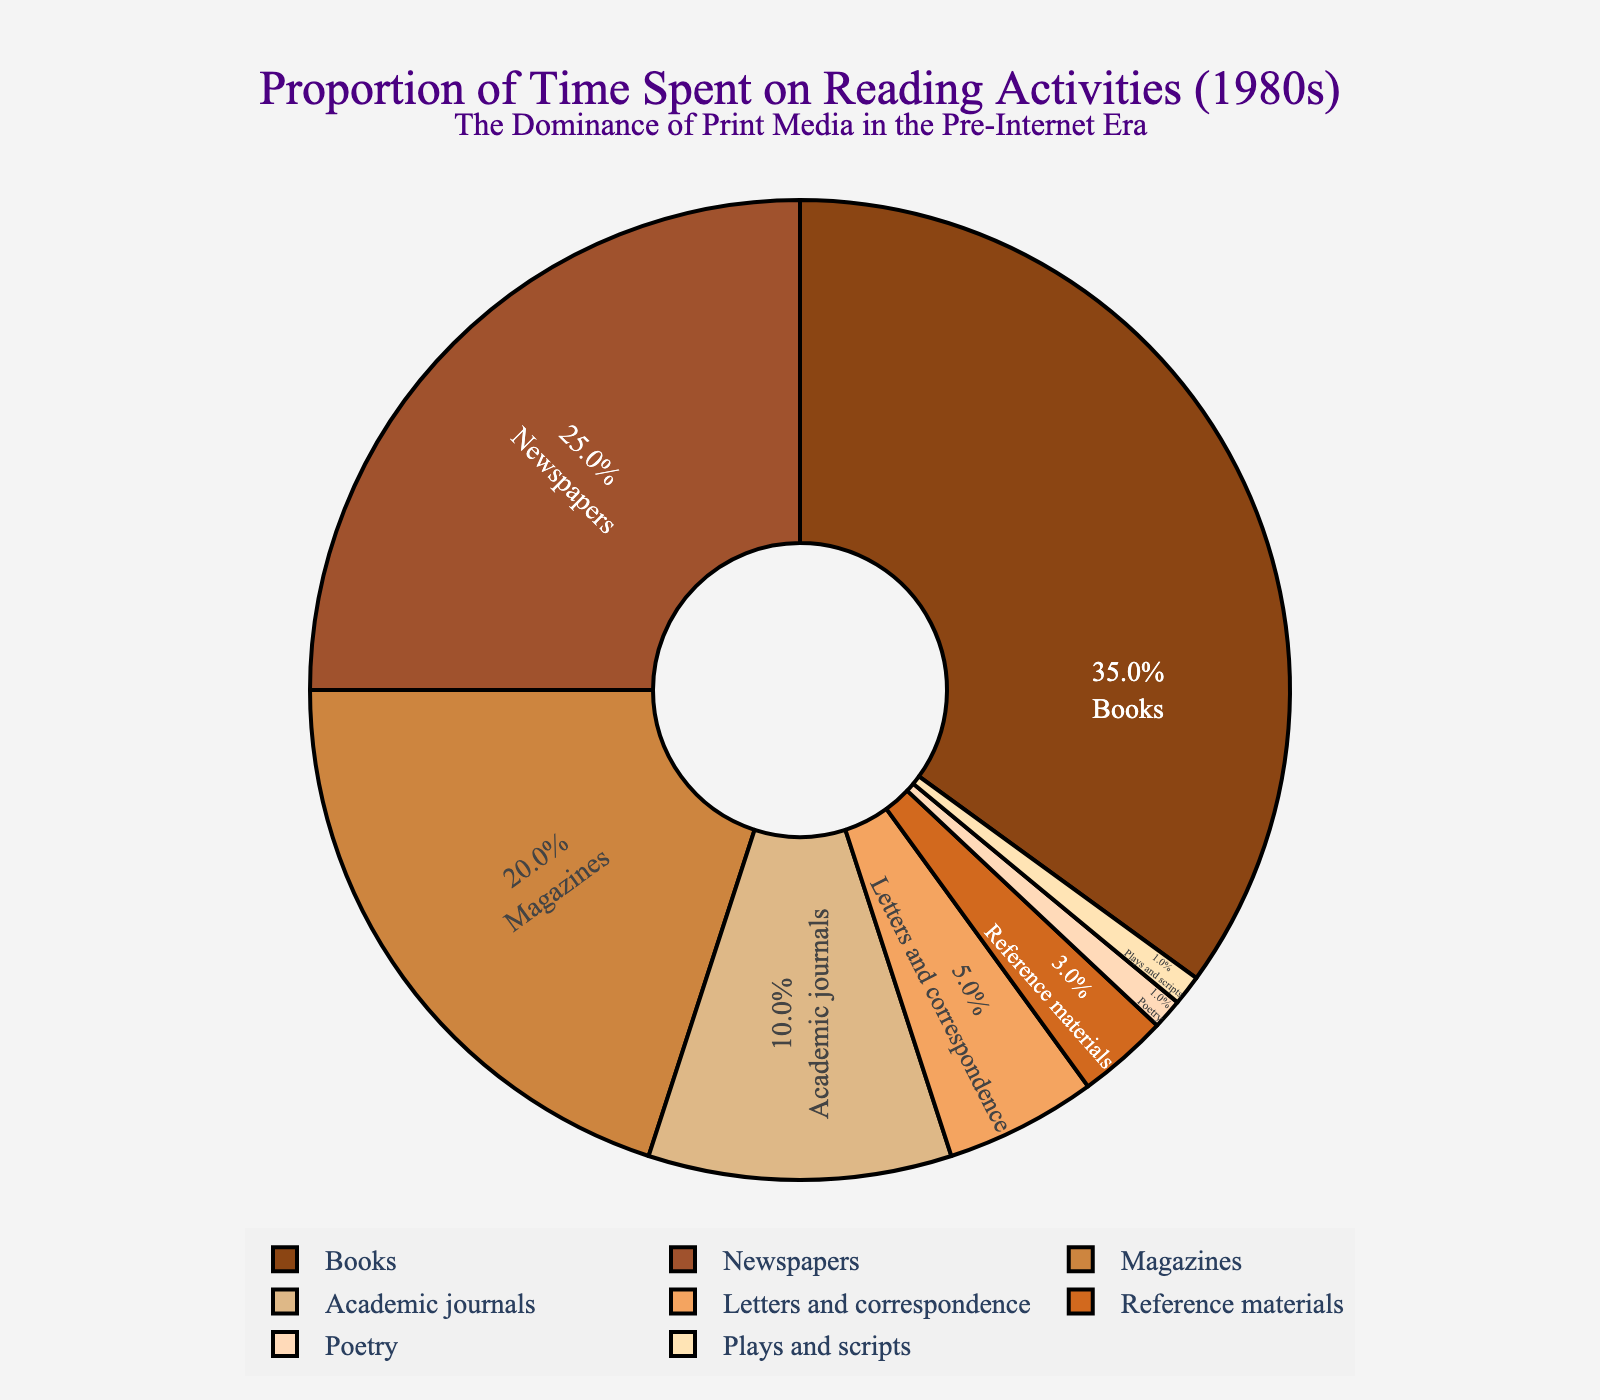What activity accounted for the highest proportion of reading time in the 1980s? The figure shows that "Books" is the largest segment, indicating that they accounted for the highest proportion of reading time.
Answer: Books How much more time was spent reading books compared to magazines? The figure shows that 35% of the time was spent on books and 20% on magazines. The difference is calculated as 35% - 20% = 15%.
Answer: 15% What is the combined percentage of time spent reading newspapers and academic journals? The figure shows that newspapers account for 25% and academic journals for 10%. Summing these gives 25% + 10% = 35%.
Answer: 35% Which reading activities each accounted for the least percentage of time and what is their combined total percentage? The figure shows that both "Poetry" and "Plays and scripts" account for 1% each. Their combined total is 1% + 1% = 2%.
Answer: Poetry and Plays and scripts, 2% How much time in total was devoted to reading letters, reference materials, poetry, and plays? According to the figure, letters account for 5%, reference materials for 3%, poetry for 1%, and plays for 1%. Summing these gives 5% + 3% + 1% + 1% = 10%.
Answer: 10% Which activity is closer in proportion to academic journals: magazines or letters and correspondence? The figure shows that academic journals account for 10%, magazines 20%, and letters and correspondence 5%. The difference with magazines is 20% - 10% = 10%, and with letters and correspondence, it is 10% - 5% = 5%. Since 5% is smaller than 10%, letters and correspondence are closer in proportion.
Answer: Letters and correspondence What is the ratio of time spent reading books to newspapers? The figure shows that 35% of the time was spent on books and 25% on newspapers. The ratio is calculated as 35:25, which simplifies to 7:5.
Answer: 7:5 By how much does the time spent on books exceed the combined time spent on reference materials and plays? The figure shows that 35% of the time was spent on books, 3% on reference materials, and 1% on plays. The combined time for reference materials and plays is 3% + 1% = 4%. Therefore, the excess time spent on books is 35% - 4% = 31%.
Answer: 31% 